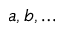<formula> <loc_0><loc_0><loc_500><loc_500>a , b , \dots</formula> 